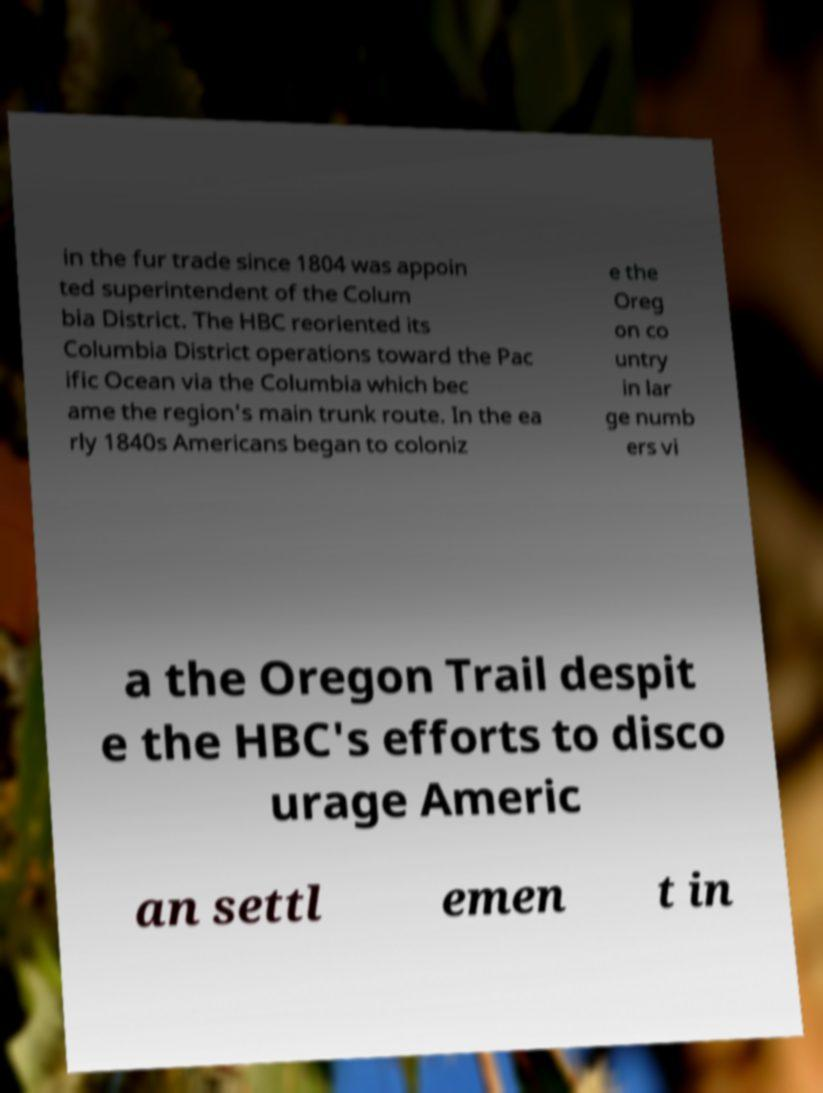What messages or text are displayed in this image? I need them in a readable, typed format. in the fur trade since 1804 was appoin ted superintendent of the Colum bia District. The HBC reoriented its Columbia District operations toward the Pac ific Ocean via the Columbia which bec ame the region's main trunk route. In the ea rly 1840s Americans began to coloniz e the Oreg on co untry in lar ge numb ers vi a the Oregon Trail despit e the HBC's efforts to disco urage Americ an settl emen t in 